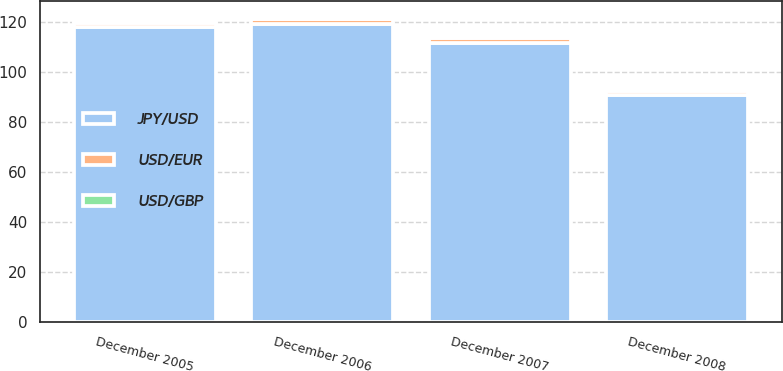Convert chart. <chart><loc_0><loc_0><loc_500><loc_500><stacked_bar_chart><ecel><fcel>December 2005<fcel>December 2006<fcel>December 2007<fcel>December 2008<nl><fcel>USD/GBP<fcel>1.18<fcel>1.32<fcel>1.46<fcel>1.4<nl><fcel>USD/EUR<fcel>1.72<fcel>1.96<fcel>1.99<fcel>1.46<nl><fcel>JPY/USD<fcel>117.92<fcel>119<fcel>111.44<fcel>90.73<nl></chart> 